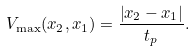<formula> <loc_0><loc_0><loc_500><loc_500>V _ { \max } ( x _ { 2 } , x _ { 1 } ) = \frac { \left | x _ { 2 } - x _ { 1 } \right | } { t _ { p } } .</formula> 